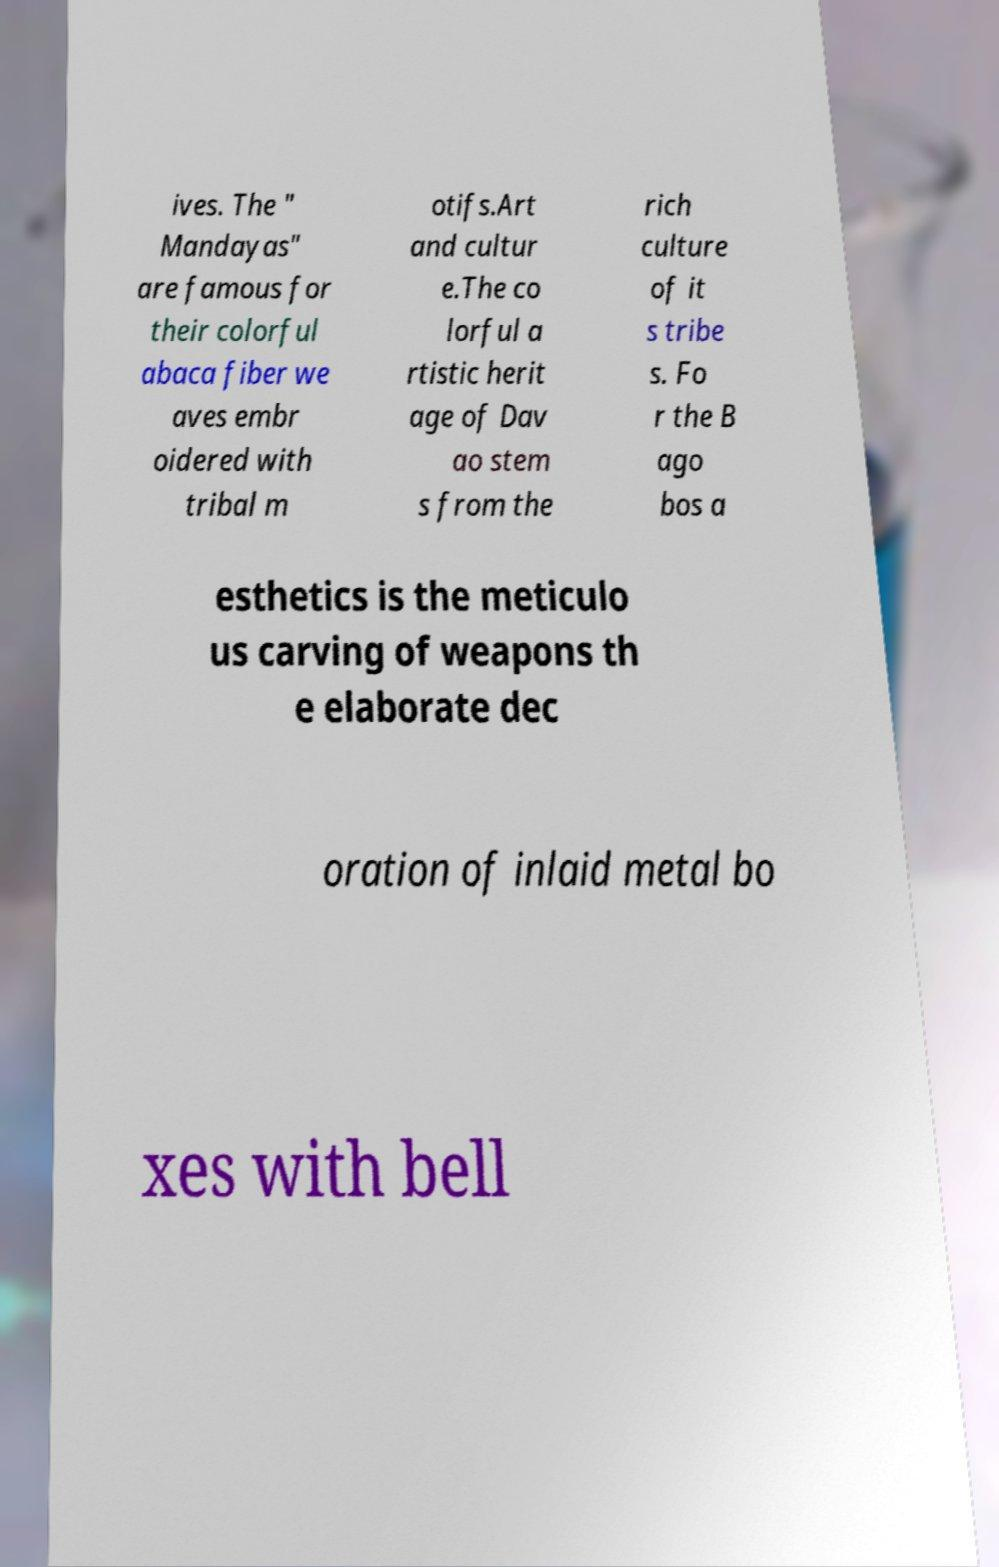Can you accurately transcribe the text from the provided image for me? ives. The " Mandayas" are famous for their colorful abaca fiber we aves embr oidered with tribal m otifs.Art and cultur e.The co lorful a rtistic herit age of Dav ao stem s from the rich culture of it s tribe s. Fo r the B ago bos a esthetics is the meticulo us carving of weapons th e elaborate dec oration of inlaid metal bo xes with bell 